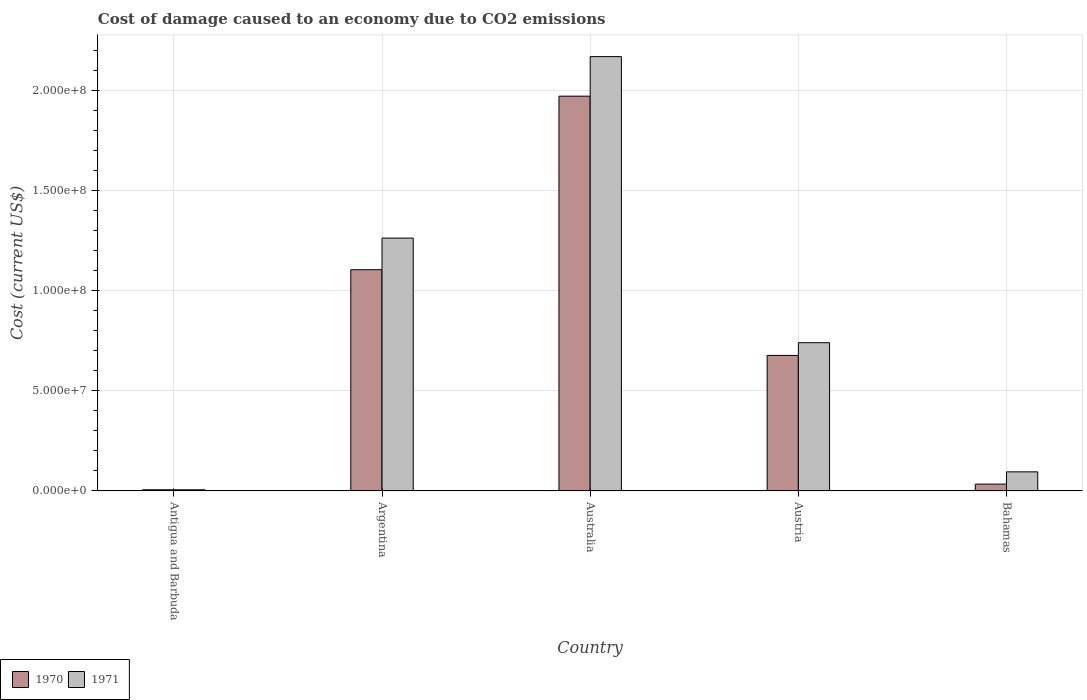How many different coloured bars are there?
Ensure brevity in your answer.  2. How many groups of bars are there?
Your answer should be very brief. 5. How many bars are there on the 5th tick from the left?
Your response must be concise. 2. What is the label of the 4th group of bars from the left?
Give a very brief answer. Austria. What is the cost of damage caused due to CO2 emissisons in 1971 in Australia?
Keep it short and to the point. 2.17e+08. Across all countries, what is the maximum cost of damage caused due to CO2 emissisons in 1970?
Make the answer very short. 1.97e+08. Across all countries, what is the minimum cost of damage caused due to CO2 emissisons in 1970?
Keep it short and to the point. 6.17e+05. In which country was the cost of damage caused due to CO2 emissisons in 1971 minimum?
Offer a terse response. Antigua and Barbuda. What is the total cost of damage caused due to CO2 emissisons in 1971 in the graph?
Offer a very short reply. 4.27e+08. What is the difference between the cost of damage caused due to CO2 emissisons in 1970 in Antigua and Barbuda and that in Bahamas?
Offer a terse response. -2.82e+06. What is the difference between the cost of damage caused due to CO2 emissisons in 1970 in Australia and the cost of damage caused due to CO2 emissisons in 1971 in Argentina?
Offer a terse response. 7.08e+07. What is the average cost of damage caused due to CO2 emissisons in 1970 per country?
Ensure brevity in your answer.  7.58e+07. What is the difference between the cost of damage caused due to CO2 emissisons of/in 1971 and cost of damage caused due to CO2 emissisons of/in 1970 in Bahamas?
Provide a short and direct response. 6.12e+06. What is the ratio of the cost of damage caused due to CO2 emissisons in 1970 in Australia to that in Austria?
Your answer should be very brief. 2.91. Is the cost of damage caused due to CO2 emissisons in 1971 in Antigua and Barbuda less than that in Austria?
Ensure brevity in your answer.  Yes. Is the difference between the cost of damage caused due to CO2 emissisons in 1971 in Austria and Bahamas greater than the difference between the cost of damage caused due to CO2 emissisons in 1970 in Austria and Bahamas?
Give a very brief answer. Yes. What is the difference between the highest and the second highest cost of damage caused due to CO2 emissisons in 1971?
Give a very brief answer. 1.43e+08. What is the difference between the highest and the lowest cost of damage caused due to CO2 emissisons in 1971?
Keep it short and to the point. 2.16e+08. In how many countries, is the cost of damage caused due to CO2 emissisons in 1970 greater than the average cost of damage caused due to CO2 emissisons in 1970 taken over all countries?
Provide a short and direct response. 2. Is the sum of the cost of damage caused due to CO2 emissisons in 1971 in Antigua and Barbuda and Austria greater than the maximum cost of damage caused due to CO2 emissisons in 1970 across all countries?
Provide a short and direct response. No. Are all the bars in the graph horizontal?
Your response must be concise. No. How many countries are there in the graph?
Your response must be concise. 5. What is the difference between two consecutive major ticks on the Y-axis?
Give a very brief answer. 5.00e+07. How are the legend labels stacked?
Give a very brief answer. Horizontal. What is the title of the graph?
Provide a short and direct response. Cost of damage caused to an economy due to CO2 emissions. What is the label or title of the Y-axis?
Provide a short and direct response. Cost (current US$). What is the Cost (current US$) in 1970 in Antigua and Barbuda?
Provide a succinct answer. 6.17e+05. What is the Cost (current US$) in 1971 in Antigua and Barbuda?
Keep it short and to the point. 6.04e+05. What is the Cost (current US$) of 1970 in Argentina?
Offer a terse response. 1.10e+08. What is the Cost (current US$) of 1971 in Argentina?
Give a very brief answer. 1.26e+08. What is the Cost (current US$) of 1970 in Australia?
Your answer should be very brief. 1.97e+08. What is the Cost (current US$) in 1971 in Australia?
Your answer should be very brief. 2.17e+08. What is the Cost (current US$) of 1970 in Austria?
Provide a succinct answer. 6.77e+07. What is the Cost (current US$) of 1971 in Austria?
Offer a terse response. 7.40e+07. What is the Cost (current US$) of 1970 in Bahamas?
Make the answer very short. 3.44e+06. What is the Cost (current US$) of 1971 in Bahamas?
Offer a very short reply. 9.55e+06. Across all countries, what is the maximum Cost (current US$) of 1970?
Give a very brief answer. 1.97e+08. Across all countries, what is the maximum Cost (current US$) in 1971?
Provide a succinct answer. 2.17e+08. Across all countries, what is the minimum Cost (current US$) in 1970?
Your response must be concise. 6.17e+05. Across all countries, what is the minimum Cost (current US$) of 1971?
Give a very brief answer. 6.04e+05. What is the total Cost (current US$) of 1970 in the graph?
Provide a short and direct response. 3.79e+08. What is the total Cost (current US$) of 1971 in the graph?
Offer a terse response. 4.27e+08. What is the difference between the Cost (current US$) in 1970 in Antigua and Barbuda and that in Argentina?
Give a very brief answer. -1.10e+08. What is the difference between the Cost (current US$) of 1971 in Antigua and Barbuda and that in Argentina?
Provide a short and direct response. -1.26e+08. What is the difference between the Cost (current US$) of 1970 in Antigua and Barbuda and that in Australia?
Your answer should be compact. -1.96e+08. What is the difference between the Cost (current US$) in 1971 in Antigua and Barbuda and that in Australia?
Give a very brief answer. -2.16e+08. What is the difference between the Cost (current US$) of 1970 in Antigua and Barbuda and that in Austria?
Your response must be concise. -6.70e+07. What is the difference between the Cost (current US$) in 1971 in Antigua and Barbuda and that in Austria?
Your answer should be compact. -7.34e+07. What is the difference between the Cost (current US$) of 1970 in Antigua and Barbuda and that in Bahamas?
Provide a succinct answer. -2.82e+06. What is the difference between the Cost (current US$) in 1971 in Antigua and Barbuda and that in Bahamas?
Offer a very short reply. -8.95e+06. What is the difference between the Cost (current US$) in 1970 in Argentina and that in Australia?
Offer a terse response. -8.66e+07. What is the difference between the Cost (current US$) in 1971 in Argentina and that in Australia?
Provide a succinct answer. -9.06e+07. What is the difference between the Cost (current US$) of 1970 in Argentina and that in Austria?
Give a very brief answer. 4.28e+07. What is the difference between the Cost (current US$) in 1971 in Argentina and that in Austria?
Your answer should be very brief. 5.22e+07. What is the difference between the Cost (current US$) in 1970 in Argentina and that in Bahamas?
Ensure brevity in your answer.  1.07e+08. What is the difference between the Cost (current US$) of 1971 in Argentina and that in Bahamas?
Provide a succinct answer. 1.17e+08. What is the difference between the Cost (current US$) in 1970 in Australia and that in Austria?
Make the answer very short. 1.29e+08. What is the difference between the Cost (current US$) of 1971 in Australia and that in Austria?
Offer a very short reply. 1.43e+08. What is the difference between the Cost (current US$) in 1970 in Australia and that in Bahamas?
Your answer should be very brief. 1.94e+08. What is the difference between the Cost (current US$) of 1971 in Australia and that in Bahamas?
Make the answer very short. 2.07e+08. What is the difference between the Cost (current US$) in 1970 in Austria and that in Bahamas?
Your answer should be compact. 6.42e+07. What is the difference between the Cost (current US$) of 1971 in Austria and that in Bahamas?
Ensure brevity in your answer.  6.45e+07. What is the difference between the Cost (current US$) in 1970 in Antigua and Barbuda and the Cost (current US$) in 1971 in Argentina?
Make the answer very short. -1.26e+08. What is the difference between the Cost (current US$) of 1970 in Antigua and Barbuda and the Cost (current US$) of 1971 in Australia?
Make the answer very short. -2.16e+08. What is the difference between the Cost (current US$) in 1970 in Antigua and Barbuda and the Cost (current US$) in 1971 in Austria?
Your answer should be very brief. -7.34e+07. What is the difference between the Cost (current US$) of 1970 in Antigua and Barbuda and the Cost (current US$) of 1971 in Bahamas?
Offer a terse response. -8.94e+06. What is the difference between the Cost (current US$) of 1970 in Argentina and the Cost (current US$) of 1971 in Australia?
Your answer should be compact. -1.06e+08. What is the difference between the Cost (current US$) of 1970 in Argentina and the Cost (current US$) of 1971 in Austria?
Provide a succinct answer. 3.64e+07. What is the difference between the Cost (current US$) of 1970 in Argentina and the Cost (current US$) of 1971 in Bahamas?
Provide a succinct answer. 1.01e+08. What is the difference between the Cost (current US$) in 1970 in Australia and the Cost (current US$) in 1971 in Austria?
Provide a short and direct response. 1.23e+08. What is the difference between the Cost (current US$) in 1970 in Australia and the Cost (current US$) in 1971 in Bahamas?
Offer a very short reply. 1.87e+08. What is the difference between the Cost (current US$) in 1970 in Austria and the Cost (current US$) in 1971 in Bahamas?
Give a very brief answer. 5.81e+07. What is the average Cost (current US$) of 1970 per country?
Your answer should be very brief. 7.58e+07. What is the average Cost (current US$) of 1971 per country?
Your answer should be very brief. 8.54e+07. What is the difference between the Cost (current US$) in 1970 and Cost (current US$) in 1971 in Antigua and Barbuda?
Your answer should be very brief. 1.31e+04. What is the difference between the Cost (current US$) of 1970 and Cost (current US$) of 1971 in Argentina?
Offer a terse response. -1.58e+07. What is the difference between the Cost (current US$) in 1970 and Cost (current US$) in 1971 in Australia?
Ensure brevity in your answer.  -1.98e+07. What is the difference between the Cost (current US$) in 1970 and Cost (current US$) in 1971 in Austria?
Your response must be concise. -6.35e+06. What is the difference between the Cost (current US$) in 1970 and Cost (current US$) in 1971 in Bahamas?
Your answer should be compact. -6.12e+06. What is the ratio of the Cost (current US$) of 1970 in Antigua and Barbuda to that in Argentina?
Keep it short and to the point. 0.01. What is the ratio of the Cost (current US$) in 1971 in Antigua and Barbuda to that in Argentina?
Offer a very short reply. 0. What is the ratio of the Cost (current US$) in 1970 in Antigua and Barbuda to that in Australia?
Provide a short and direct response. 0. What is the ratio of the Cost (current US$) in 1971 in Antigua and Barbuda to that in Australia?
Give a very brief answer. 0. What is the ratio of the Cost (current US$) in 1970 in Antigua and Barbuda to that in Austria?
Make the answer very short. 0.01. What is the ratio of the Cost (current US$) in 1971 in Antigua and Barbuda to that in Austria?
Keep it short and to the point. 0.01. What is the ratio of the Cost (current US$) of 1970 in Antigua and Barbuda to that in Bahamas?
Give a very brief answer. 0.18. What is the ratio of the Cost (current US$) in 1971 in Antigua and Barbuda to that in Bahamas?
Provide a short and direct response. 0.06. What is the ratio of the Cost (current US$) in 1970 in Argentina to that in Australia?
Your response must be concise. 0.56. What is the ratio of the Cost (current US$) of 1971 in Argentina to that in Australia?
Offer a terse response. 0.58. What is the ratio of the Cost (current US$) of 1970 in Argentina to that in Austria?
Keep it short and to the point. 1.63. What is the ratio of the Cost (current US$) in 1971 in Argentina to that in Austria?
Offer a terse response. 1.71. What is the ratio of the Cost (current US$) of 1970 in Argentina to that in Bahamas?
Your answer should be very brief. 32.14. What is the ratio of the Cost (current US$) of 1971 in Argentina to that in Bahamas?
Make the answer very short. 13.21. What is the ratio of the Cost (current US$) of 1970 in Australia to that in Austria?
Keep it short and to the point. 2.91. What is the ratio of the Cost (current US$) in 1971 in Australia to that in Austria?
Your answer should be compact. 2.93. What is the ratio of the Cost (current US$) in 1970 in Australia to that in Bahamas?
Keep it short and to the point. 57.34. What is the ratio of the Cost (current US$) of 1971 in Australia to that in Bahamas?
Give a very brief answer. 22.69. What is the ratio of the Cost (current US$) of 1970 in Austria to that in Bahamas?
Provide a succinct answer. 19.69. What is the ratio of the Cost (current US$) in 1971 in Austria to that in Bahamas?
Provide a short and direct response. 7.75. What is the difference between the highest and the second highest Cost (current US$) of 1970?
Your answer should be compact. 8.66e+07. What is the difference between the highest and the second highest Cost (current US$) in 1971?
Your answer should be compact. 9.06e+07. What is the difference between the highest and the lowest Cost (current US$) in 1970?
Your answer should be very brief. 1.96e+08. What is the difference between the highest and the lowest Cost (current US$) of 1971?
Give a very brief answer. 2.16e+08. 